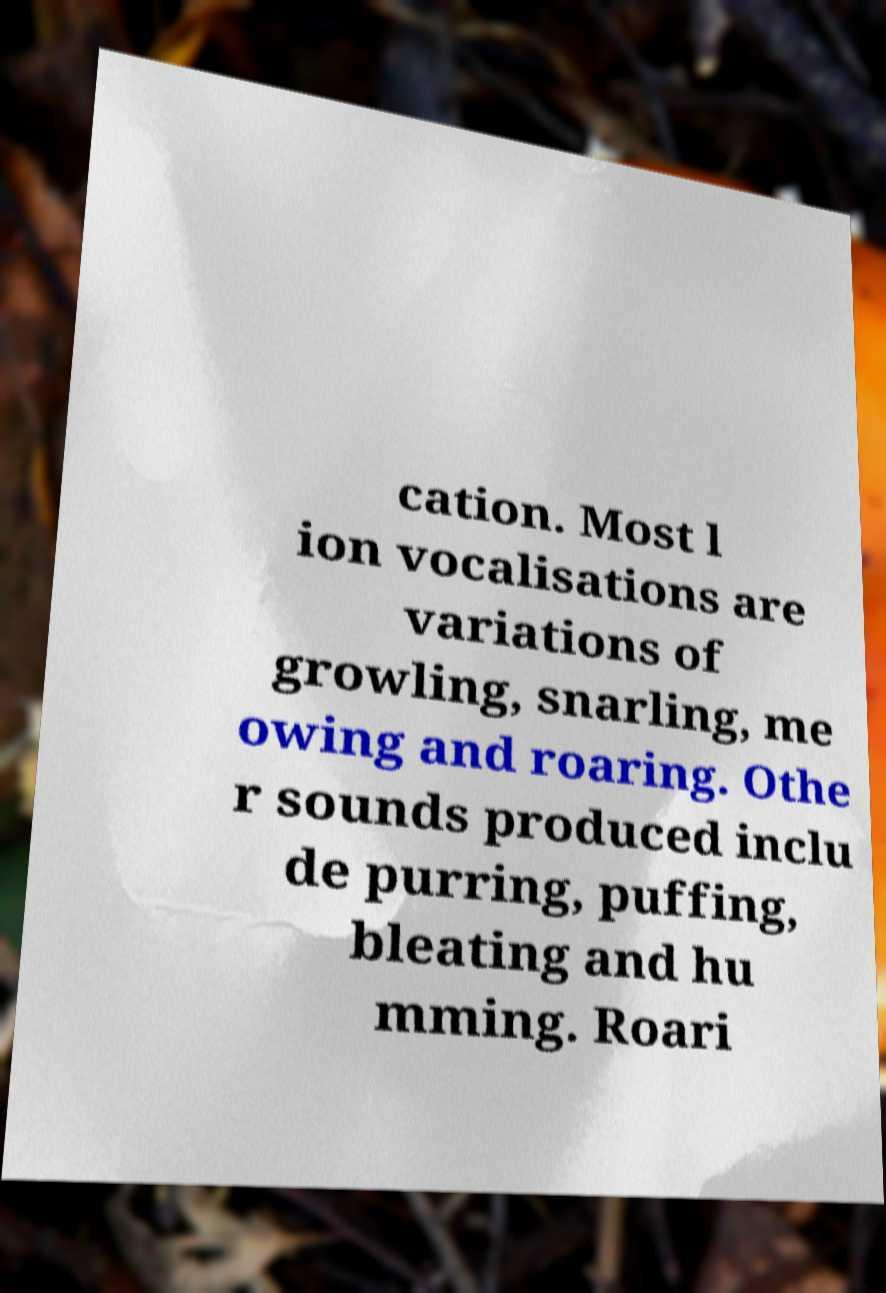Can you read and provide the text displayed in the image?This photo seems to have some interesting text. Can you extract and type it out for me? cation. Most l ion vocalisations are variations of growling, snarling, me owing and roaring. Othe r sounds produced inclu de purring, puffing, bleating and hu mming. Roari 